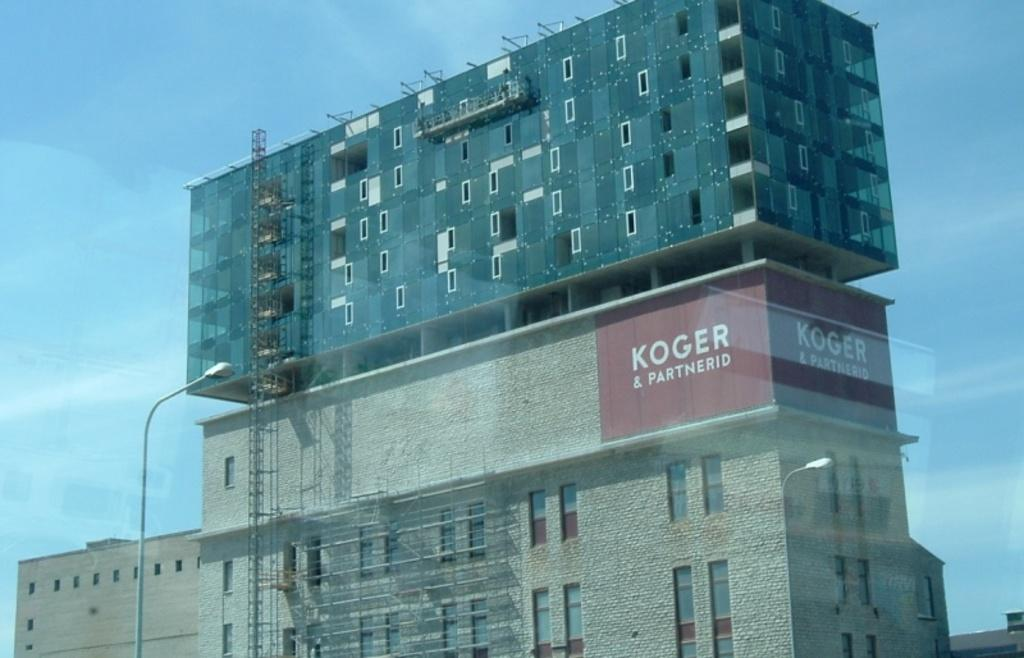What is the setting of the image? The image has an outside view. What can be seen in front of the building in the image? There is a street pole in front of a building. What is visible in the background of the image? The sky is visible in the background of the image. What type of coat is hanging on the street pole in the image? There is no coat present on the street pole in the image. What type of pot is visible on the building in the image? There is no pot visible on the building in the image. 